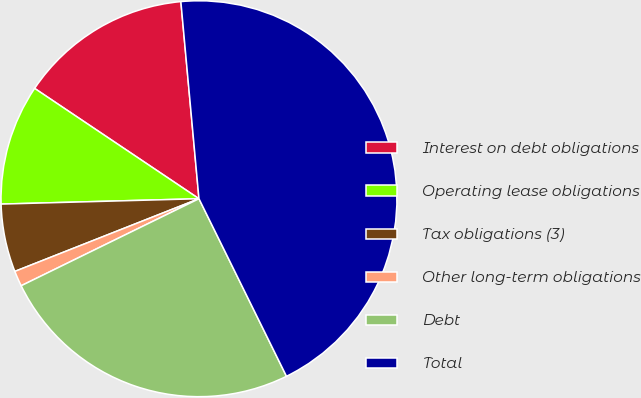Convert chart. <chart><loc_0><loc_0><loc_500><loc_500><pie_chart><fcel>Interest on debt obligations<fcel>Operating lease obligations<fcel>Tax obligations (3)<fcel>Other long-term obligations<fcel>Debt<fcel>Total<nl><fcel>14.13%<fcel>9.84%<fcel>5.55%<fcel>1.26%<fcel>25.04%<fcel>44.16%<nl></chart> 